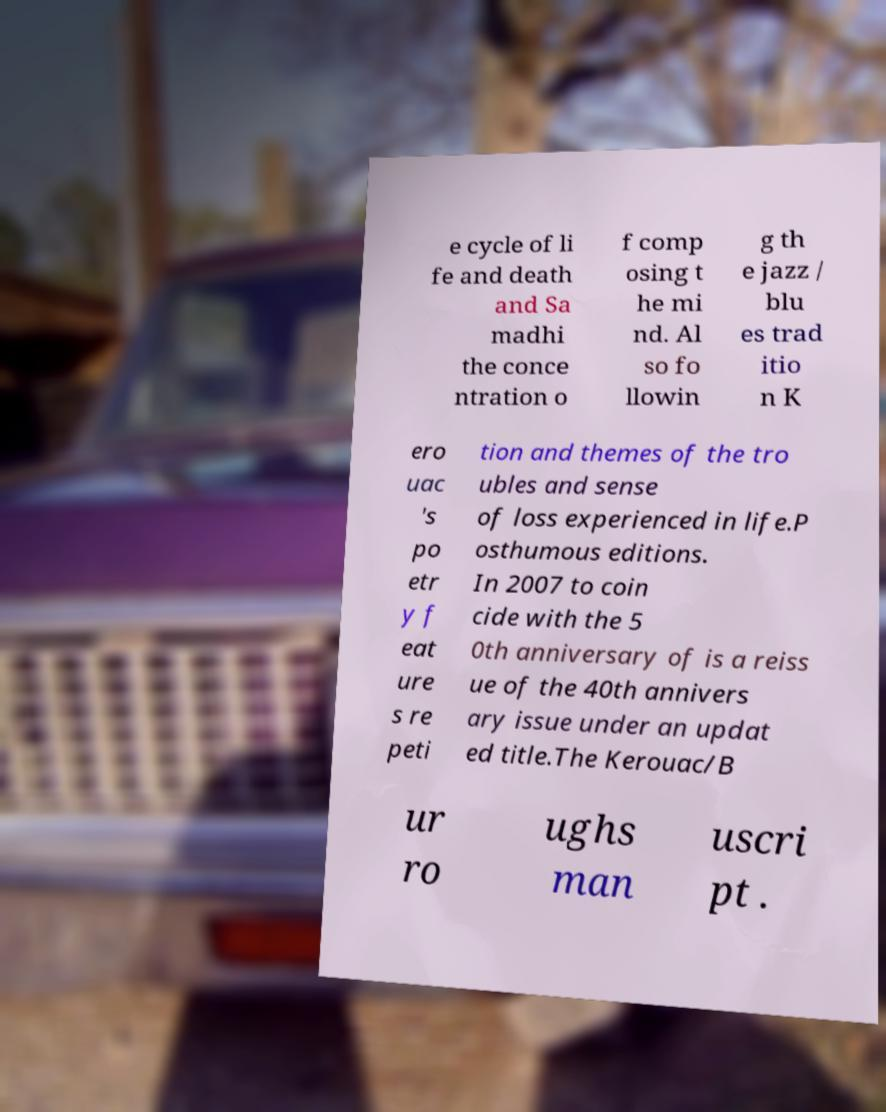Can you read and provide the text displayed in the image?This photo seems to have some interesting text. Can you extract and type it out for me? e cycle of li fe and death and Sa madhi the conce ntration o f comp osing t he mi nd. Al so fo llowin g th e jazz / blu es trad itio n K ero uac 's po etr y f eat ure s re peti tion and themes of the tro ubles and sense of loss experienced in life.P osthumous editions. In 2007 to coin cide with the 5 0th anniversary of is a reiss ue of the 40th annivers ary issue under an updat ed title.The Kerouac/B ur ro ughs man uscri pt . 